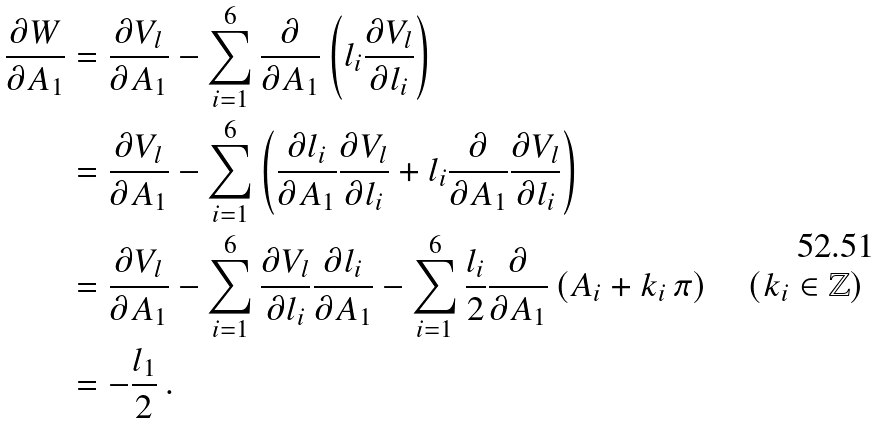Convert formula to latex. <formula><loc_0><loc_0><loc_500><loc_500>\frac { \partial W } { \partial A _ { 1 } } & = \frac { \partial V _ { l } } { \partial A _ { 1 } } - \sum _ { i = 1 } ^ { 6 } \frac { \partial } { \partial A _ { 1 } } \left ( l _ { i } \frac { \partial V _ { l } } { \partial l _ { i } } \right ) \\ & = \frac { \partial V _ { l } } { \partial A _ { 1 } } - \sum _ { i = 1 } ^ { 6 } \left ( \frac { \partial l _ { i } } { \partial A _ { 1 } } \frac { \partial V _ { l } } { \partial l _ { i } } + l _ { i } \frac { \partial } { \partial A _ { 1 } } \frac { \partial V _ { l } } { \partial l _ { i } } \right ) \\ & = \frac { \partial V _ { l } } { \partial A _ { 1 } } - \sum _ { i = 1 } ^ { 6 } \frac { \partial V _ { l } } { \partial l _ { i } } \frac { \partial l _ { i } } { \partial A _ { 1 } } - \sum _ { i = 1 } ^ { 6 } \frac { l _ { i } } { 2 } \frac { \partial } { \partial A _ { 1 } } \left ( A _ { i } + k _ { i } \, \pi \right ) \quad ( k _ { i } \in \mathbb { Z } ) \\ & = - \frac { l _ { 1 } } { 2 } \, .</formula> 